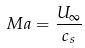Convert formula to latex. <formula><loc_0><loc_0><loc_500><loc_500>M a = \frac { U _ { \infty } } { c _ { s } }</formula> 